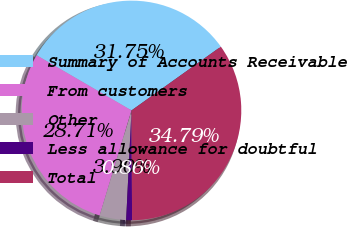Convert chart. <chart><loc_0><loc_0><loc_500><loc_500><pie_chart><fcel>Summary of Accounts Receivable<fcel>From customers<fcel>Other<fcel>Less allowance for doubtful<fcel>Total<nl><fcel>31.75%<fcel>28.71%<fcel>3.9%<fcel>0.86%<fcel>34.79%<nl></chart> 